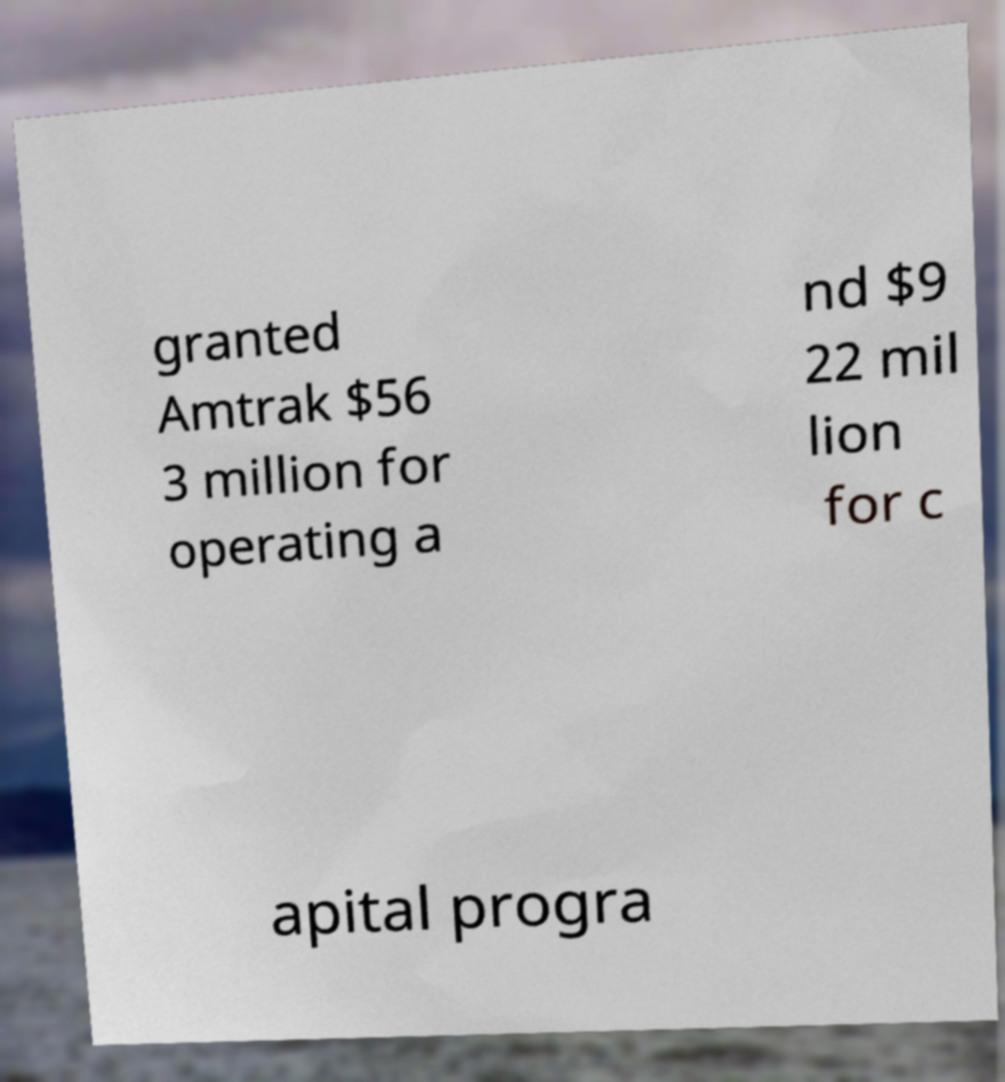For documentation purposes, I need the text within this image transcribed. Could you provide that? granted Amtrak $56 3 million for operating a nd $9 22 mil lion for c apital progra 